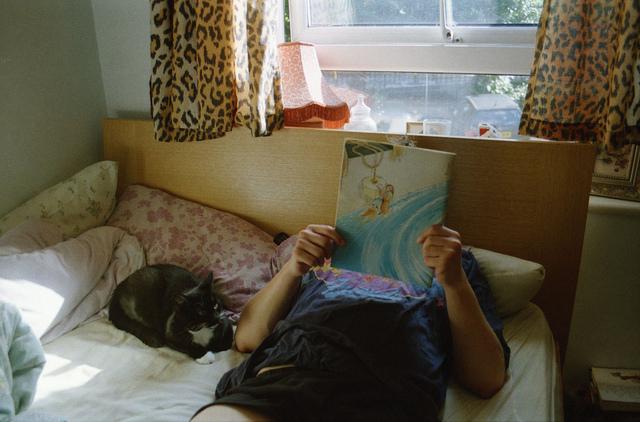About what time of day was this photo taken?
Be succinct. Morning. Is there a cat in this photo?
Write a very short answer. Yes. Is the person on the bed reading?
Give a very brief answer. Yes. 